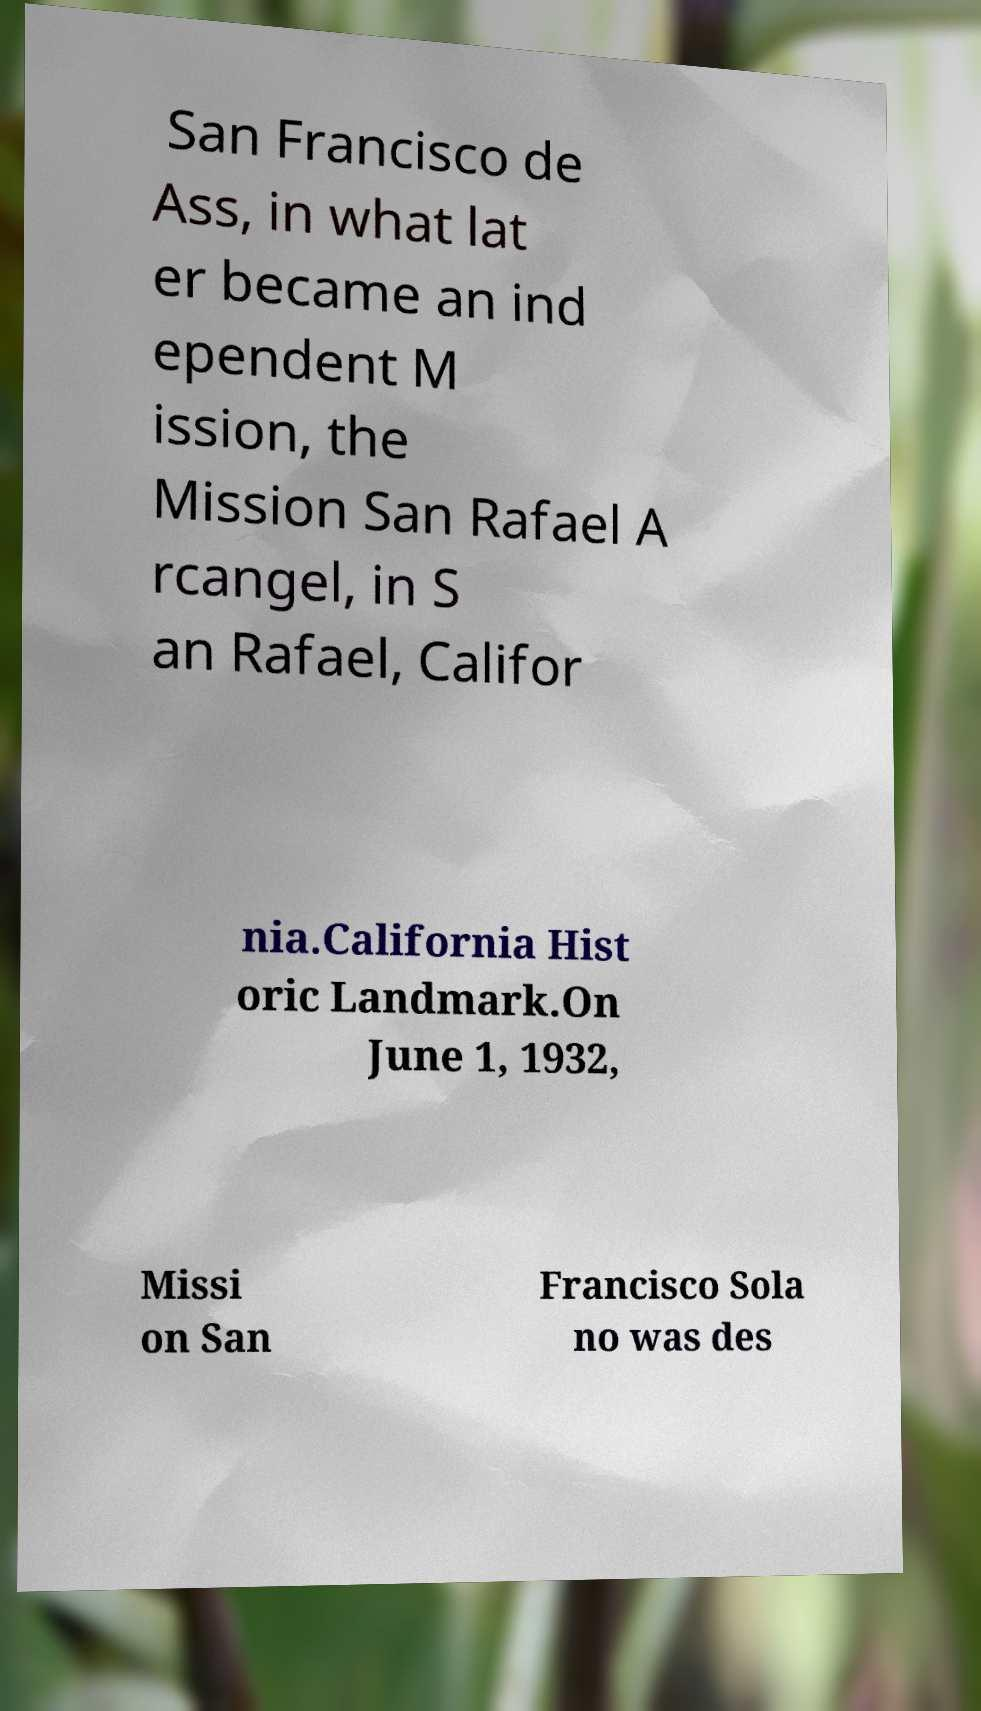Please identify and transcribe the text found in this image. San Francisco de Ass, in what lat er became an ind ependent M ission, the Mission San Rafael A rcangel, in S an Rafael, Califor nia.California Hist oric Landmark.On June 1, 1932, Missi on San Francisco Sola no was des 